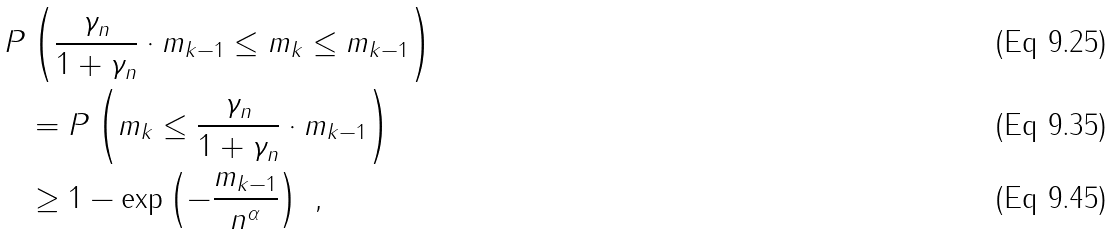<formula> <loc_0><loc_0><loc_500><loc_500>P & \left ( \frac { \gamma _ { n } } { 1 + \gamma _ { n } } \cdot m _ { k - 1 } \leq m _ { k } \leq m _ { k - 1 } \right ) \\ & = P \left ( m _ { k } \leq \frac { \gamma _ { n } } { 1 + \gamma _ { n } } \cdot m _ { k - 1 } \right ) \\ & \geq 1 - \exp \left ( - \frac { m _ { k - 1 } } { n ^ { \alpha } } \right ) \ ,</formula> 